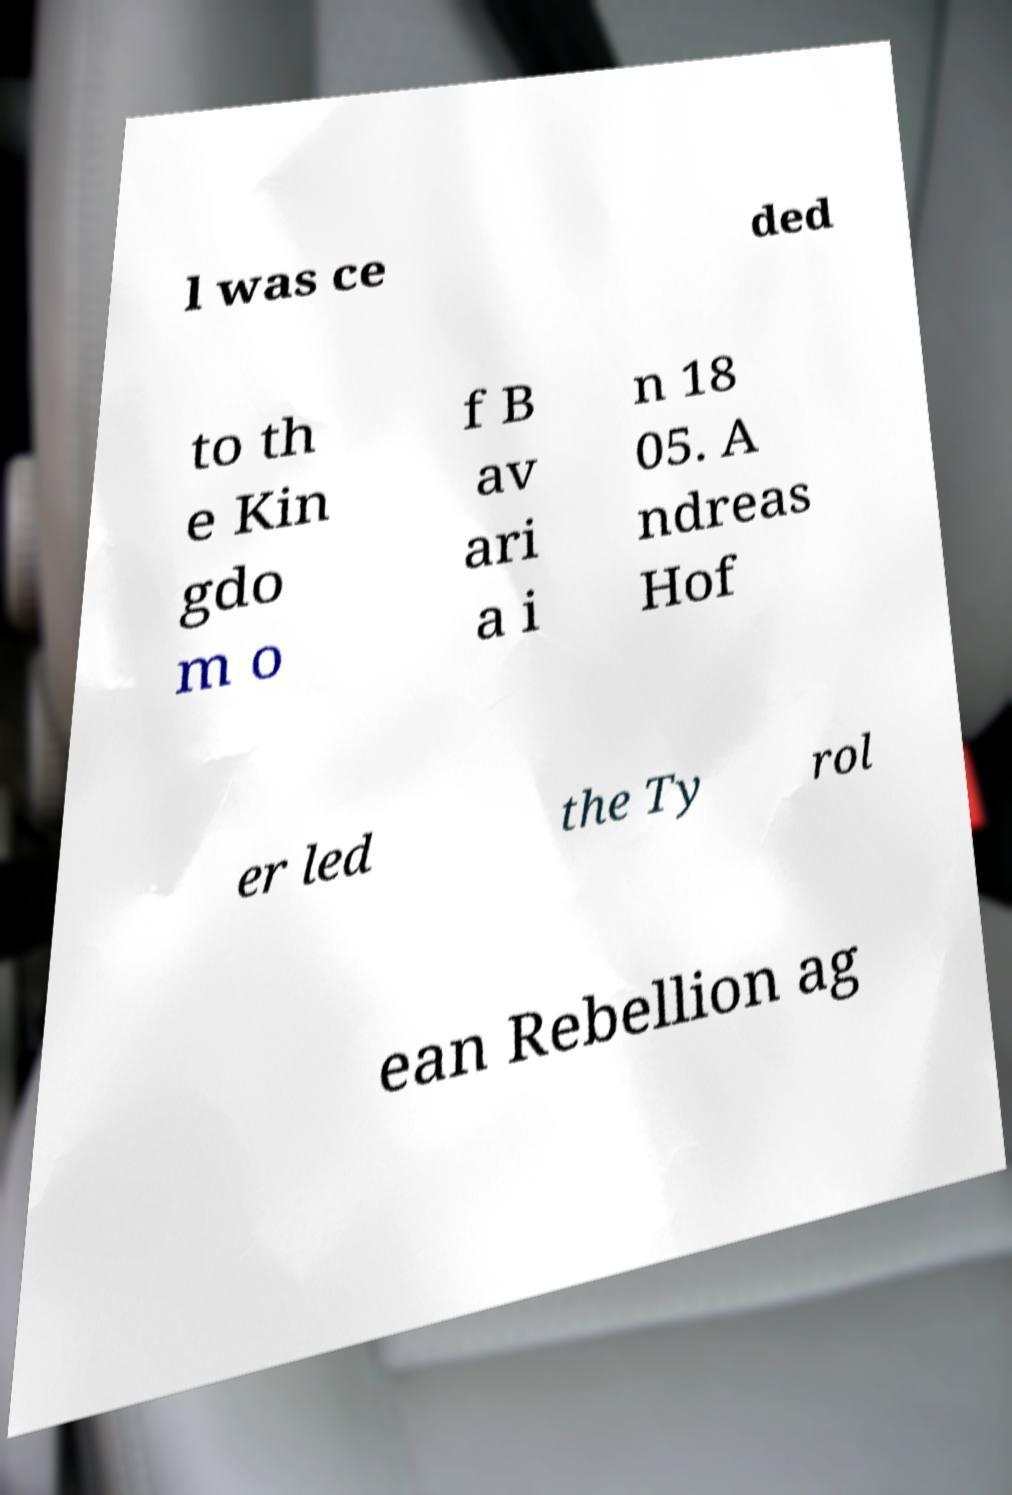What messages or text are displayed in this image? I need them in a readable, typed format. l was ce ded to th e Kin gdo m o f B av ari a i n 18 05. A ndreas Hof er led the Ty rol ean Rebellion ag 